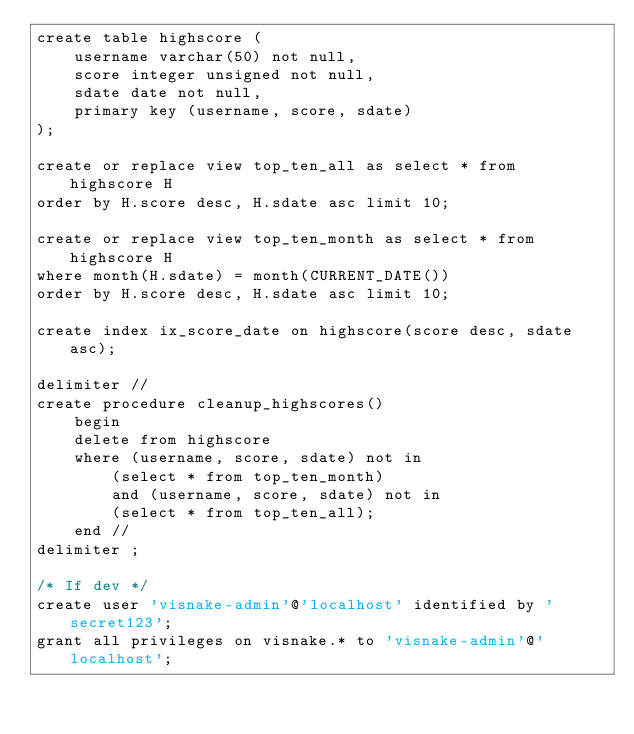<code> <loc_0><loc_0><loc_500><loc_500><_SQL_>create table highscore (
    username varchar(50) not null,
    score integer unsigned not null,
    sdate date not null,
    primary key (username, score, sdate)
);

create or replace view top_ten_all as select * from highscore H
order by H.score desc, H.sdate asc limit 10;

create or replace view top_ten_month as select * from highscore H
where month(H.sdate) = month(CURRENT_DATE())
order by H.score desc, H.sdate asc limit 10;

create index ix_score_date on highscore(score desc, sdate asc);

delimiter //
create procedure cleanup_highscores()
    begin
    delete from highscore
    where (username, score, sdate) not in
        (select * from top_ten_month)
        and (username, score, sdate) not in
        (select * from top_ten_all);
    end //
delimiter ;

/* If dev */
create user 'visnake-admin'@'localhost' identified by 'secret123';
grant all privileges on visnake.* to 'visnake-admin'@'localhost';
</code> 